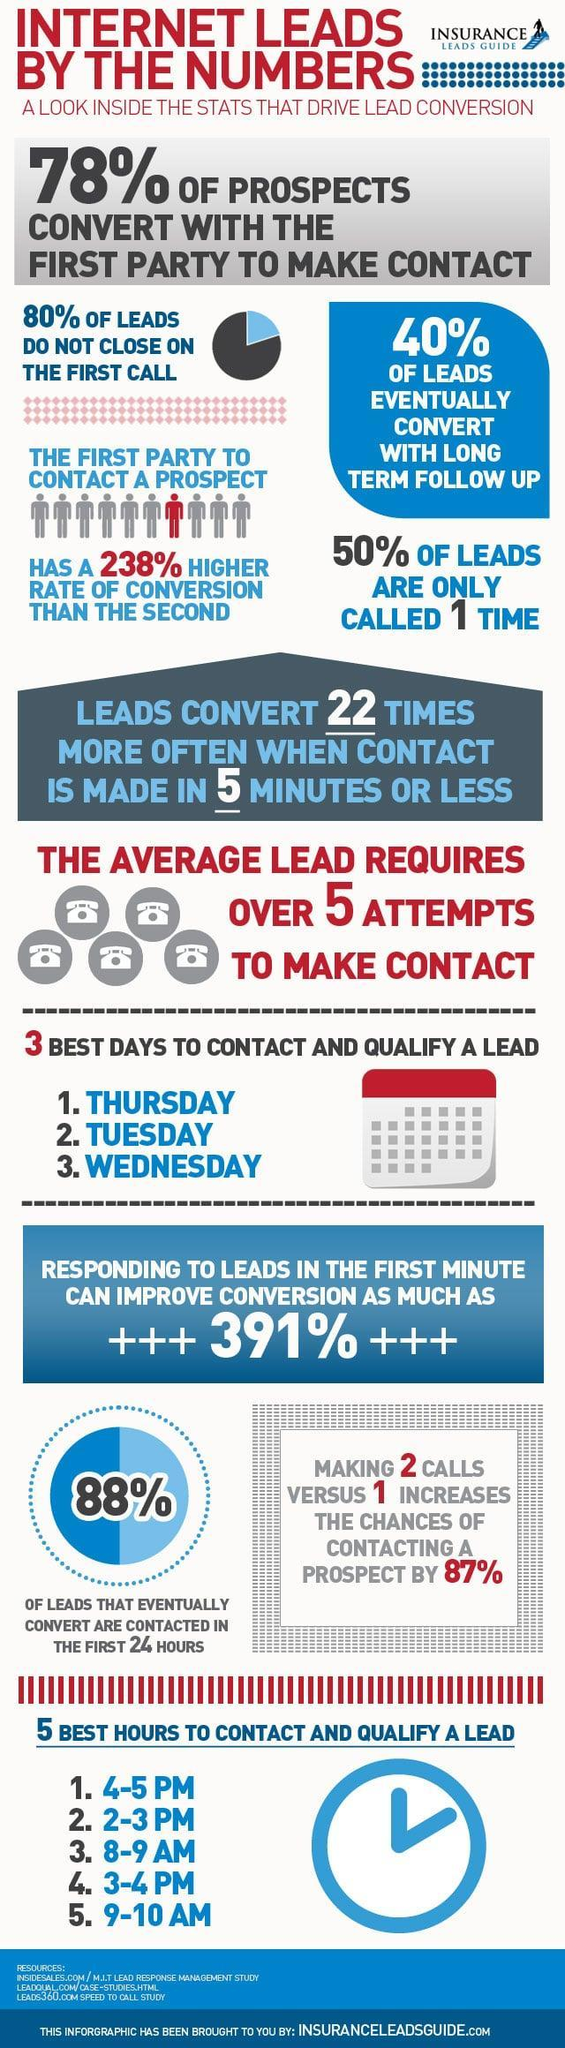What is the ideal response time that can lead to conversion rates more than 300%, 24 hours, 1 min, or 5 mins?
Answer the question with a short phrase. 1 min What are the chances for second party to convert internet leads to prospects? 22% What is the percentage of leads that are converted to prospects in the first call ? 20% 